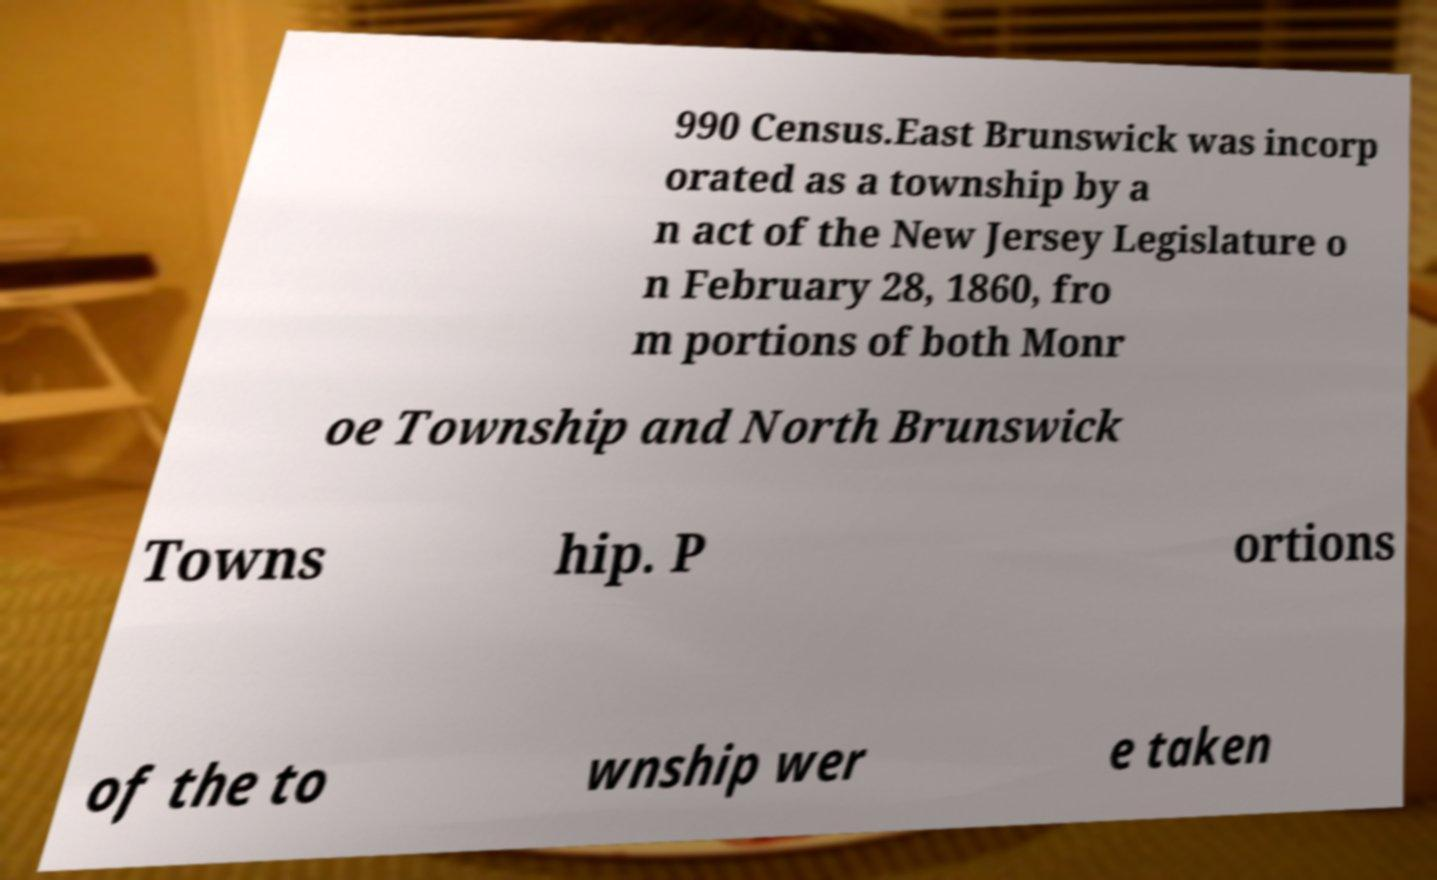For documentation purposes, I need the text within this image transcribed. Could you provide that? 990 Census.East Brunswick was incorp orated as a township by a n act of the New Jersey Legislature o n February 28, 1860, fro m portions of both Monr oe Township and North Brunswick Towns hip. P ortions of the to wnship wer e taken 